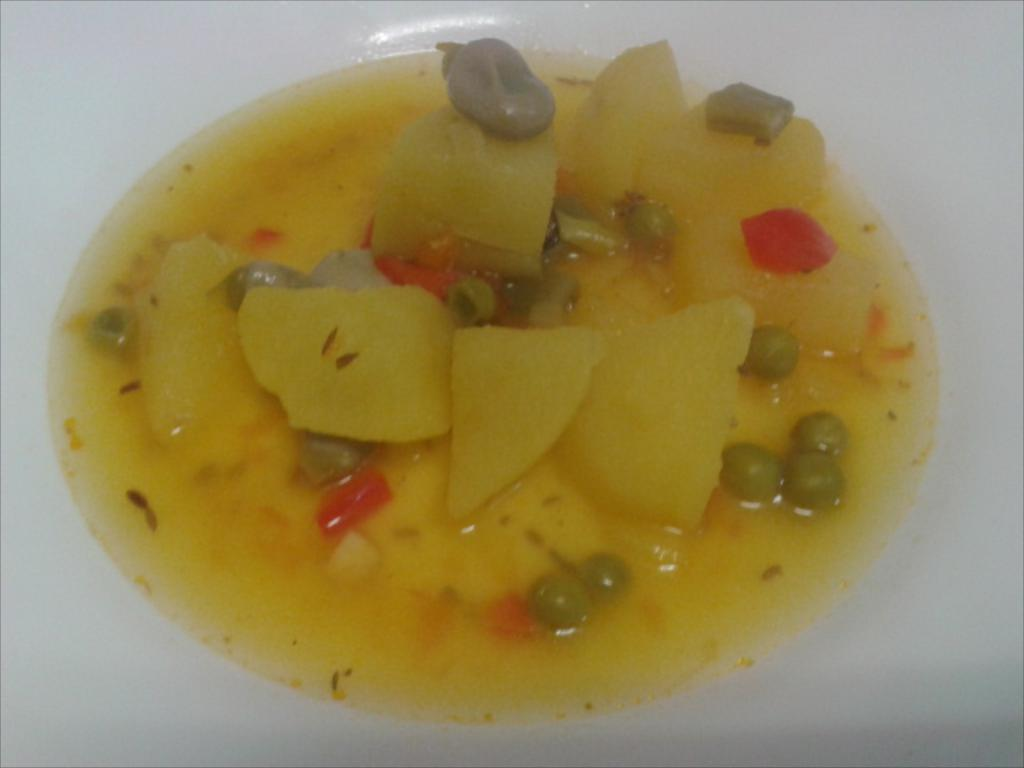What types of items can be seen in the image? There are food items in the image. What is the color of the surface where the food items are placed? The surface is white-colored. How many lawyers are present in the image? There are no lawyers present in the image; it features food items on a white surface. What type of rabbits can be seen interacting with the food items in the image? There are no rabbits present in the image; it features food items on a white surface. 